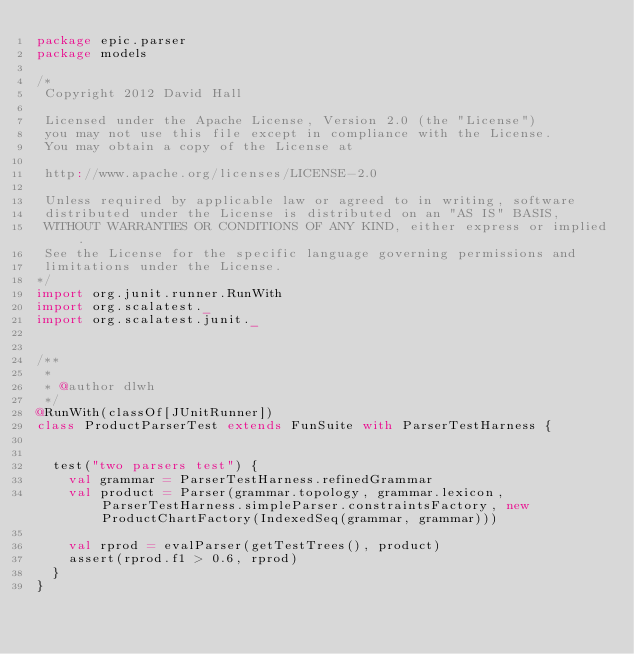Convert code to text. <code><loc_0><loc_0><loc_500><loc_500><_Scala_>package epic.parser
package models

/*
 Copyright 2012 David Hall

 Licensed under the Apache License, Version 2.0 (the "License")
 you may not use this file except in compliance with the License.
 You may obtain a copy of the License at

 http://www.apache.org/licenses/LICENSE-2.0

 Unless required by applicable law or agreed to in writing, software
 distributed under the License is distributed on an "AS IS" BASIS,
 WITHOUT WARRANTIES OR CONDITIONS OF ANY KIND, either express or implied.
 See the License for the specific language governing permissions and
 limitations under the License.
*/
import org.junit.runner.RunWith
import org.scalatest._
import org.scalatest.junit._


/**
 *
 * @author dlwh
 */
@RunWith(classOf[JUnitRunner])
class ProductParserTest extends FunSuite with ParserTestHarness {


  test("two parsers test") {
    val grammar = ParserTestHarness.refinedGrammar
    val product = Parser(grammar.topology, grammar.lexicon, ParserTestHarness.simpleParser.constraintsFactory, new ProductChartFactory(IndexedSeq(grammar, grammar)))

    val rprod = evalParser(getTestTrees(), product)
    assert(rprod.f1 > 0.6, rprod)
  }
}

</code> 